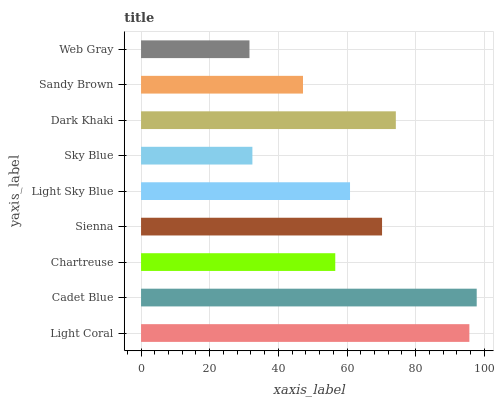Is Web Gray the minimum?
Answer yes or no. Yes. Is Cadet Blue the maximum?
Answer yes or no. Yes. Is Chartreuse the minimum?
Answer yes or no. No. Is Chartreuse the maximum?
Answer yes or no. No. Is Cadet Blue greater than Chartreuse?
Answer yes or no. Yes. Is Chartreuse less than Cadet Blue?
Answer yes or no. Yes. Is Chartreuse greater than Cadet Blue?
Answer yes or no. No. Is Cadet Blue less than Chartreuse?
Answer yes or no. No. Is Light Sky Blue the high median?
Answer yes or no. Yes. Is Light Sky Blue the low median?
Answer yes or no. Yes. Is Sienna the high median?
Answer yes or no. No. Is Cadet Blue the low median?
Answer yes or no. No. 